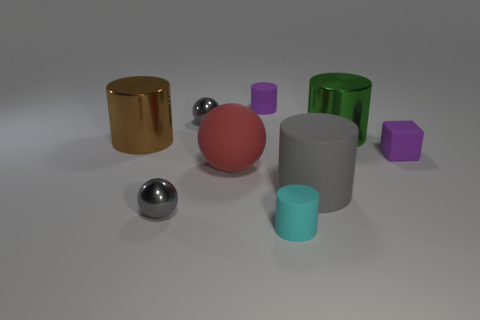What does the arrangement of these objects suggest about their purpose or context? The objects appear to be strategically placed for a comparison of shapes, colors, and textures, possibly within an educational or display context. The variety and the deliberate spacing suggest an environment designed for observation and study, rather than practical use. 